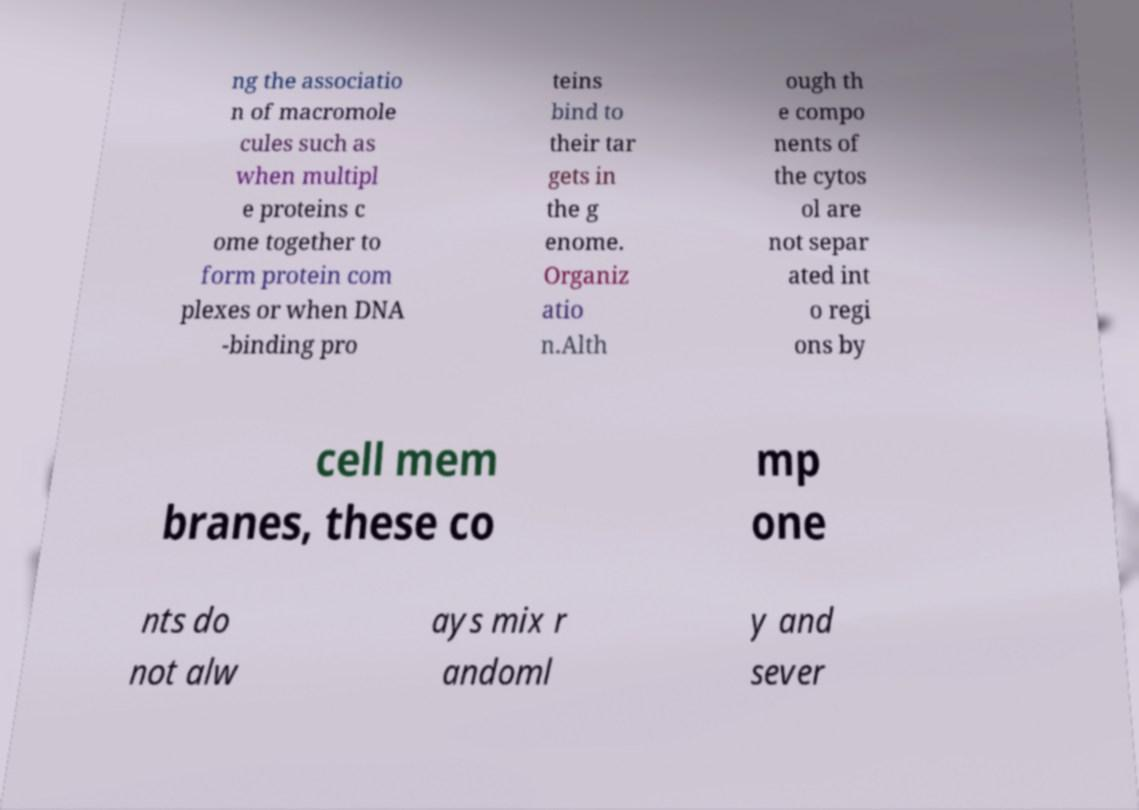What messages or text are displayed in this image? I need them in a readable, typed format. ng the associatio n of macromole cules such as when multipl e proteins c ome together to form protein com plexes or when DNA -binding pro teins bind to their tar gets in the g enome. Organiz atio n.Alth ough th e compo nents of the cytos ol are not separ ated int o regi ons by cell mem branes, these co mp one nts do not alw ays mix r andoml y and sever 